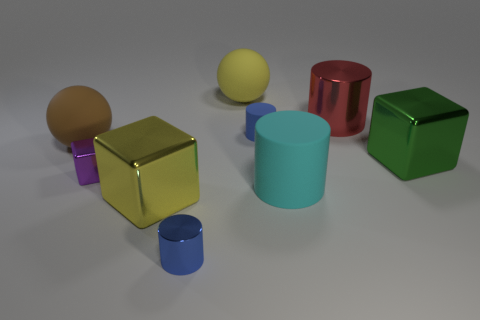Do the green shiny thing and the shiny cylinder in front of the green thing have the same size?
Offer a terse response. No. What number of rubber objects are either cyan objects or big spheres?
Make the answer very short. 3. Is there anything else that is the same material as the cyan cylinder?
Your response must be concise. Yes. There is a tiny matte thing; is it the same color as the big cylinder that is behind the green shiny cube?
Provide a succinct answer. No. The blue matte thing is what shape?
Offer a terse response. Cylinder. There is a metal cylinder that is to the left of the blue cylinder that is behind the big block that is to the left of the cyan matte cylinder; what is its size?
Ensure brevity in your answer.  Small. What number of other things are there of the same shape as the small rubber thing?
Keep it short and to the point. 3. There is a thing left of the small shiny cube; does it have the same shape as the tiny blue thing in front of the small purple metallic object?
Your answer should be compact. No. What number of cylinders are either yellow metallic objects or metal things?
Provide a short and direct response. 2. What material is the small cylinder that is to the left of the large matte ball that is behind the tiny blue object that is behind the small purple shiny block?
Keep it short and to the point. Metal. 